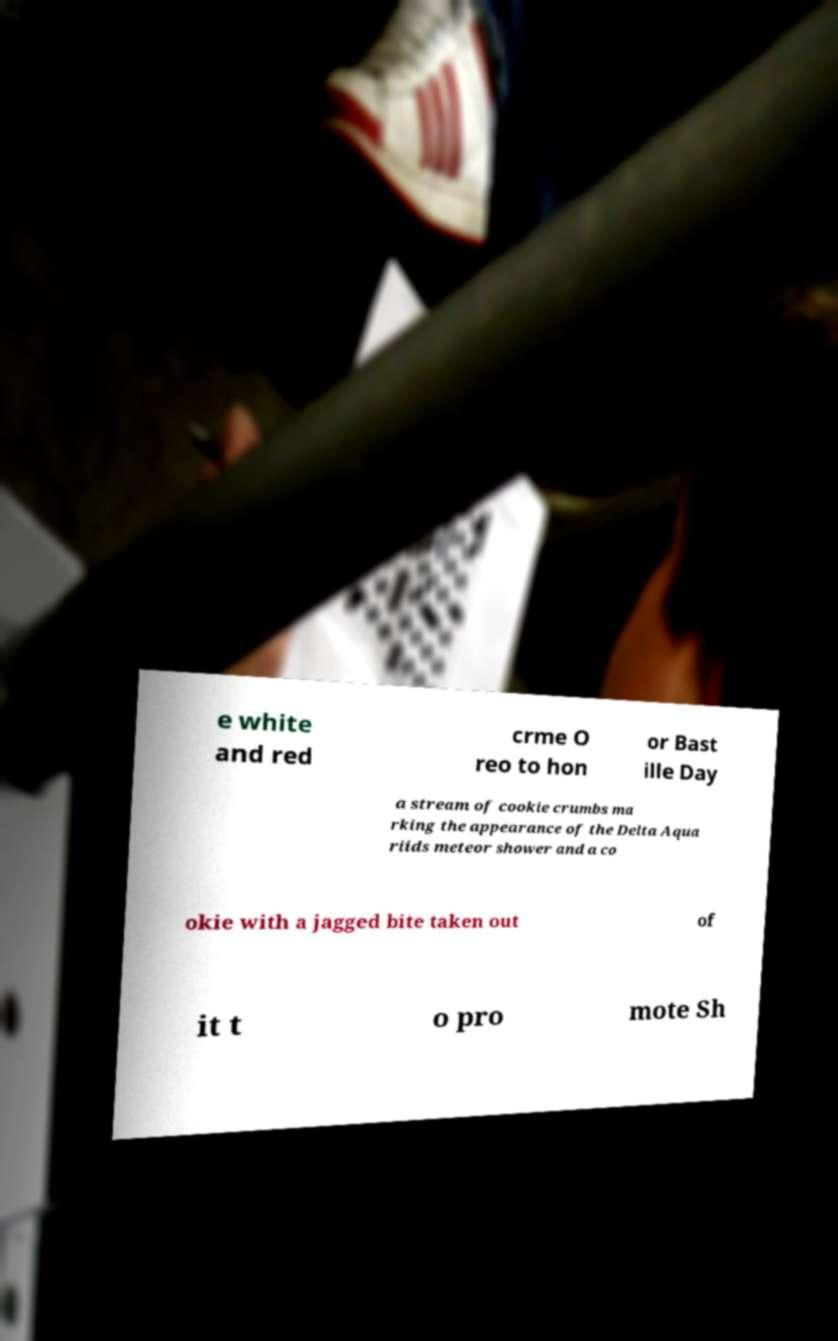Could you assist in decoding the text presented in this image and type it out clearly? e white and red crme O reo to hon or Bast ille Day a stream of cookie crumbs ma rking the appearance of the Delta Aqua riids meteor shower and a co okie with a jagged bite taken out of it t o pro mote Sh 